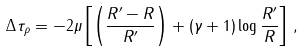Convert formula to latex. <formula><loc_0><loc_0><loc_500><loc_500>\Delta \tau _ { \rho } = - 2 \mu \left [ \left ( \frac { R ^ { \prime } - R } { R ^ { \prime } } \right ) + ( \gamma + 1 ) \log \frac { R ^ { \prime } } { R } \right ] \, ,</formula> 